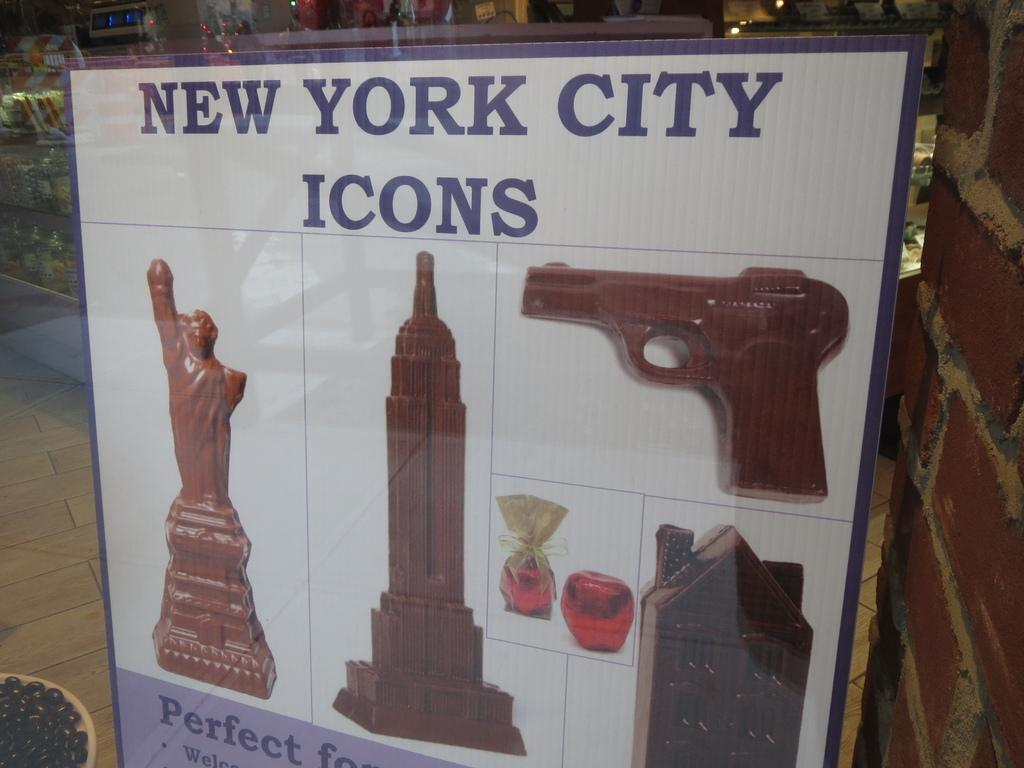<image>
Give a short and clear explanation of the subsequent image. A poster in a shop window shows chocolate shapes of a gun and buildings under the heading New York City Icons. 